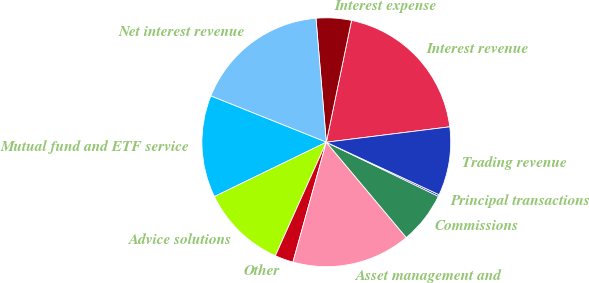<chart> <loc_0><loc_0><loc_500><loc_500><pie_chart><fcel>Interest revenue<fcel>Interest expense<fcel>Net interest revenue<fcel>Mutual fund and ETF service<fcel>Advice solutions<fcel>Other<fcel>Asset management and<fcel>Commissions<fcel>Principal transactions<fcel>Trading revenue<nl><fcel>19.78%<fcel>4.57%<fcel>17.61%<fcel>13.26%<fcel>11.09%<fcel>2.39%<fcel>15.43%<fcel>6.74%<fcel>0.22%<fcel>8.91%<nl></chart> 